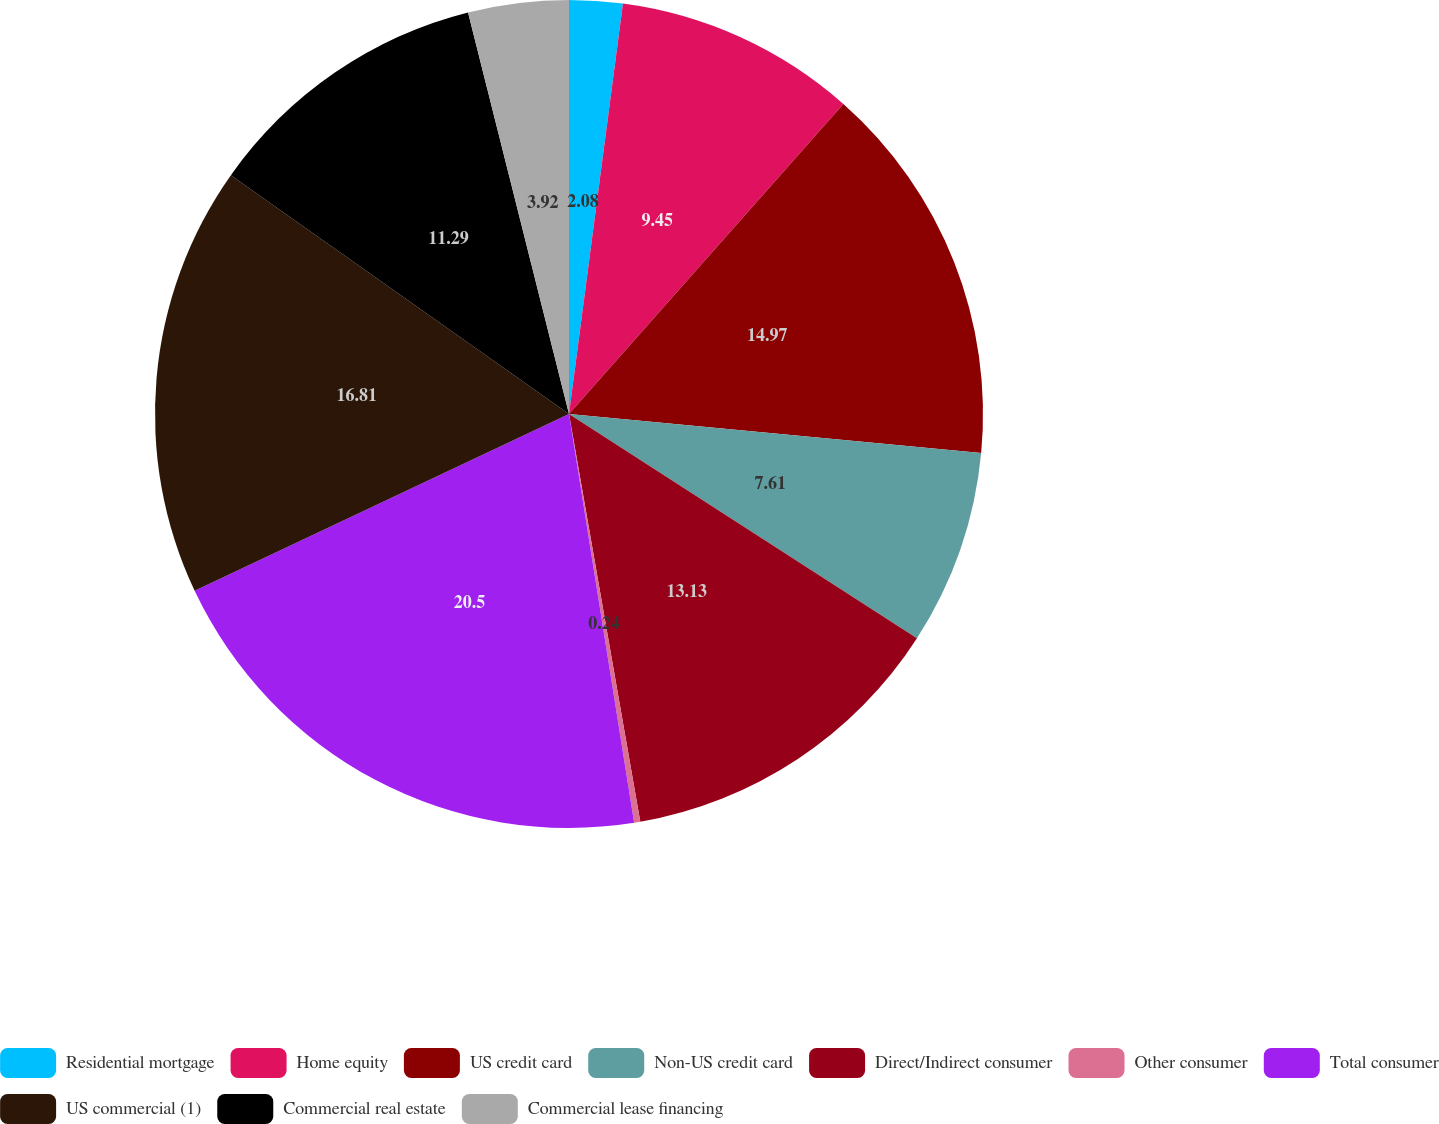<chart> <loc_0><loc_0><loc_500><loc_500><pie_chart><fcel>Residential mortgage<fcel>Home equity<fcel>US credit card<fcel>Non-US credit card<fcel>Direct/Indirect consumer<fcel>Other consumer<fcel>Total consumer<fcel>US commercial (1)<fcel>Commercial real estate<fcel>Commercial lease financing<nl><fcel>2.08%<fcel>9.45%<fcel>14.97%<fcel>7.61%<fcel>13.13%<fcel>0.24%<fcel>20.49%<fcel>16.81%<fcel>11.29%<fcel>3.92%<nl></chart> 